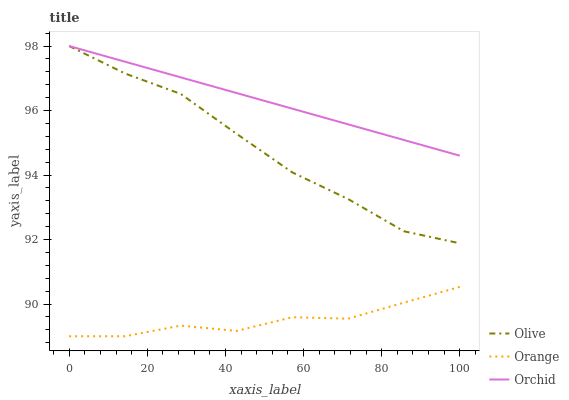Does Orange have the minimum area under the curve?
Answer yes or no. Yes. Does Orchid have the maximum area under the curve?
Answer yes or no. Yes. Does Orchid have the minimum area under the curve?
Answer yes or no. No. Does Orange have the maximum area under the curve?
Answer yes or no. No. Is Orchid the smoothest?
Answer yes or no. Yes. Is Orange the roughest?
Answer yes or no. Yes. Is Orange the smoothest?
Answer yes or no. No. Is Orchid the roughest?
Answer yes or no. No. Does Orange have the lowest value?
Answer yes or no. Yes. Does Orchid have the lowest value?
Answer yes or no. No. Does Orchid have the highest value?
Answer yes or no. Yes. Does Orange have the highest value?
Answer yes or no. No. Is Orange less than Olive?
Answer yes or no. Yes. Is Orchid greater than Orange?
Answer yes or no. Yes. Does Olive intersect Orchid?
Answer yes or no. Yes. Is Olive less than Orchid?
Answer yes or no. No. Is Olive greater than Orchid?
Answer yes or no. No. Does Orange intersect Olive?
Answer yes or no. No. 